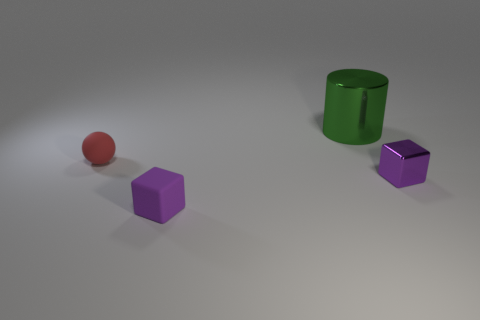The other rubber thing that is the same size as the purple rubber object is what shape?
Ensure brevity in your answer.  Sphere. How many tiny things are both on the left side of the big metal cylinder and on the right side of the big shiny object?
Your answer should be very brief. 0. There is a tiny thing that is left of the small matte block; what is it made of?
Ensure brevity in your answer.  Rubber. What size is the cube that is the same material as the big green cylinder?
Your answer should be compact. Small. Is the size of the block on the left side of the purple metallic object the same as the metal thing that is behind the red rubber object?
Your response must be concise. No. There is another purple cube that is the same size as the matte block; what is it made of?
Offer a terse response. Metal. What is the material of the tiny object that is left of the green metallic cylinder and in front of the red rubber sphere?
Offer a terse response. Rubber. Are there any large metal spheres?
Ensure brevity in your answer.  No. There is a rubber cube; is its color the same as the shiny object behind the small purple shiny block?
Keep it short and to the point. No. There is another cube that is the same color as the shiny cube; what material is it?
Offer a very short reply. Rubber. 